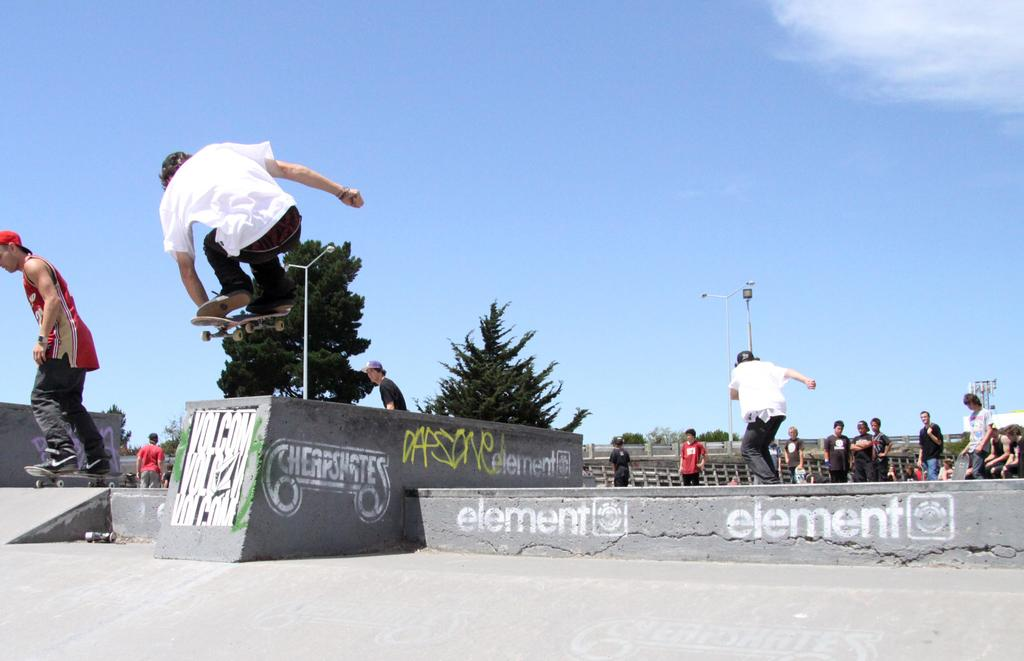What are the two men in the image doing? The two men are on skateboards in the image. Can you describe the action of one of the men? One man is in the air, likely performing a skateboard trick. What can be seen in the background of the image? There is a group of people, trees, light poles, a fence, some unspecified objects, and the sky visible in the background of the image. What type of control is being used by the man on the skateboard to stay on the edge of the ramp? There is no mention of a ramp or any control being used in the image. The man is simply in the air, likely performing a skateboard trick. Are there any mittens visible in the image? No, there are no mittens present in the image. 